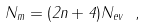<formula> <loc_0><loc_0><loc_500><loc_500>N _ { m } = ( 2 n + 4 ) N _ { e v } \ ,</formula> 